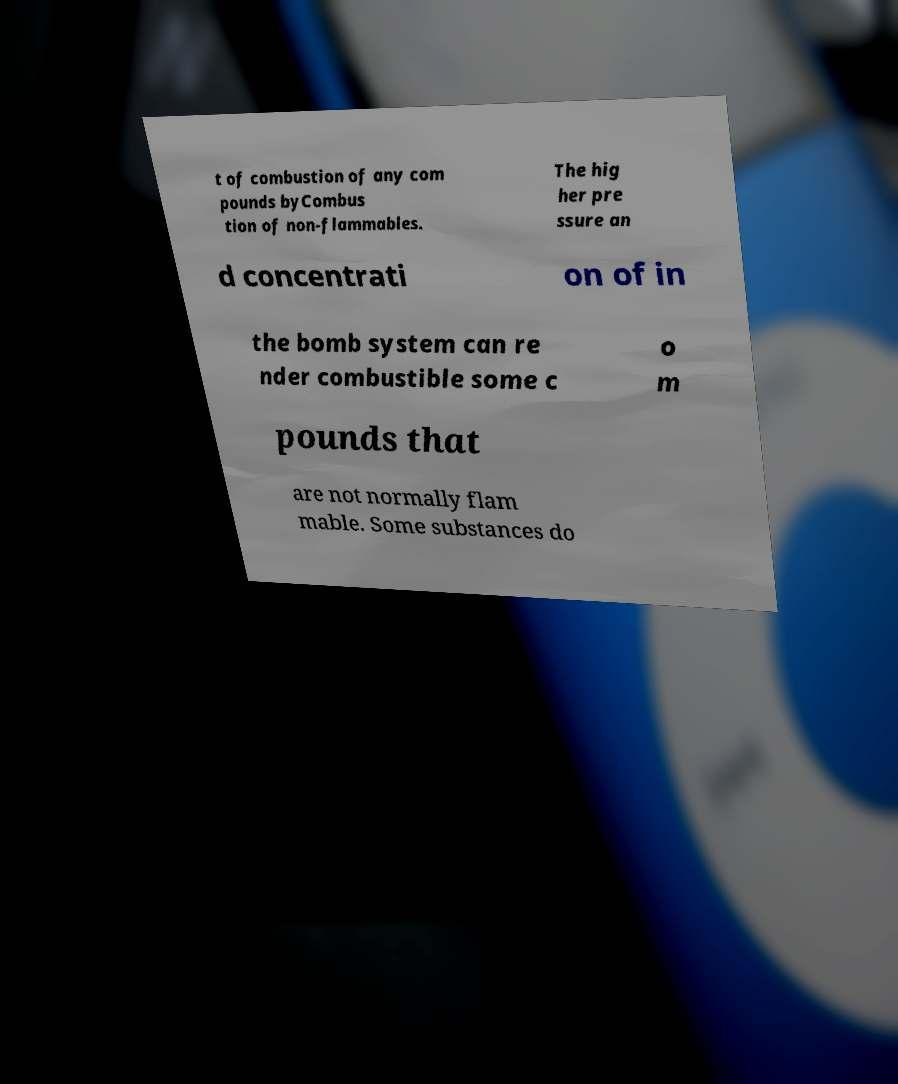Can you read and provide the text displayed in the image?This photo seems to have some interesting text. Can you extract and type it out for me? t of combustion of any com pounds byCombus tion of non-flammables. The hig her pre ssure an d concentrati on of in the bomb system can re nder combustible some c o m pounds that are not normally flam mable. Some substances do 